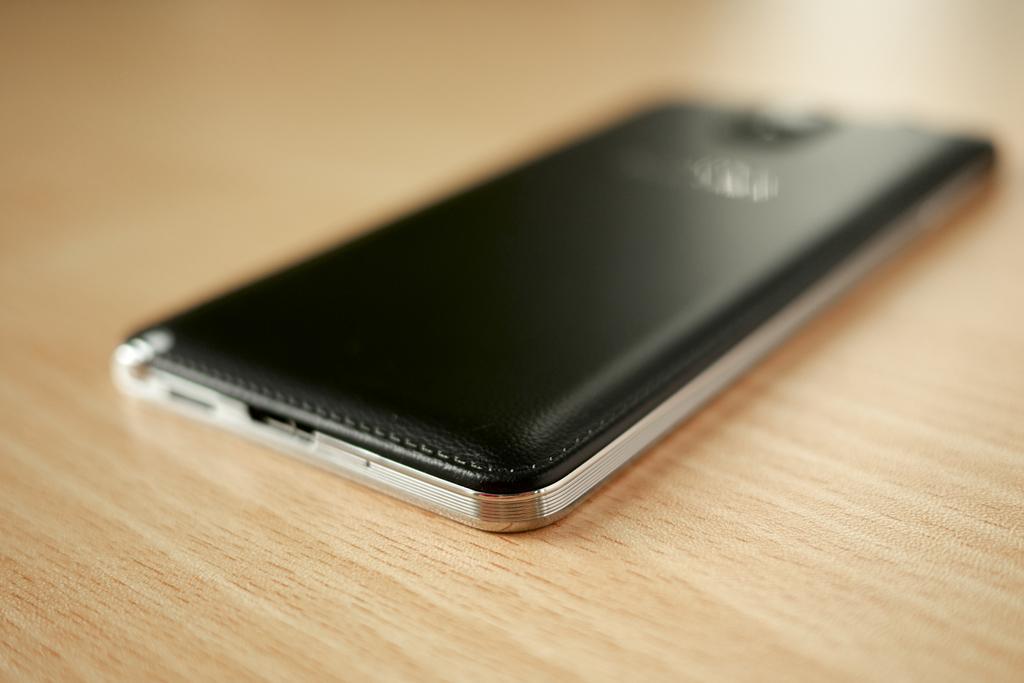Describe this image in one or two sentences. In this image we can see a device placed on the surface. 